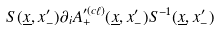Convert formula to latex. <formula><loc_0><loc_0><loc_500><loc_500>S ( \underline { x } , x _ { - } ^ { \prime } ) \partial _ { i } A _ { + } ^ { \prime ( c \ell ) } ( \underline { x } , x _ { - } ^ { \prime } ) S ^ { - 1 } ( \underline { x } , x _ { - } ^ { \prime } )</formula> 